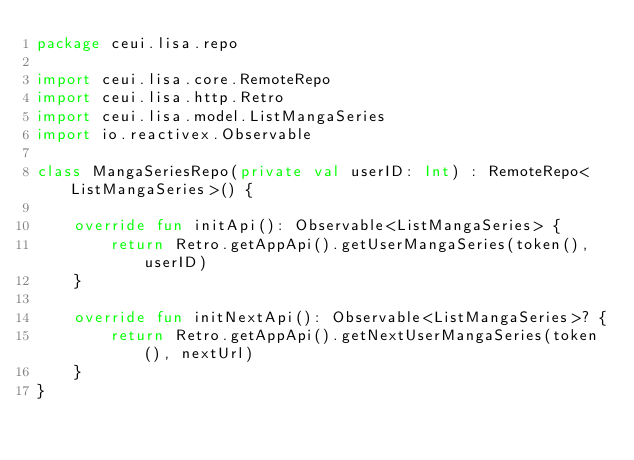<code> <loc_0><loc_0><loc_500><loc_500><_Kotlin_>package ceui.lisa.repo

import ceui.lisa.core.RemoteRepo
import ceui.lisa.http.Retro
import ceui.lisa.model.ListMangaSeries
import io.reactivex.Observable

class MangaSeriesRepo(private val userID: Int) : RemoteRepo<ListMangaSeries>() {

    override fun initApi(): Observable<ListMangaSeries> {
        return Retro.getAppApi().getUserMangaSeries(token(), userID)
    }

    override fun initNextApi(): Observable<ListMangaSeries>? {
        return Retro.getAppApi().getNextUserMangaSeries(token(), nextUrl)
    }
}</code> 